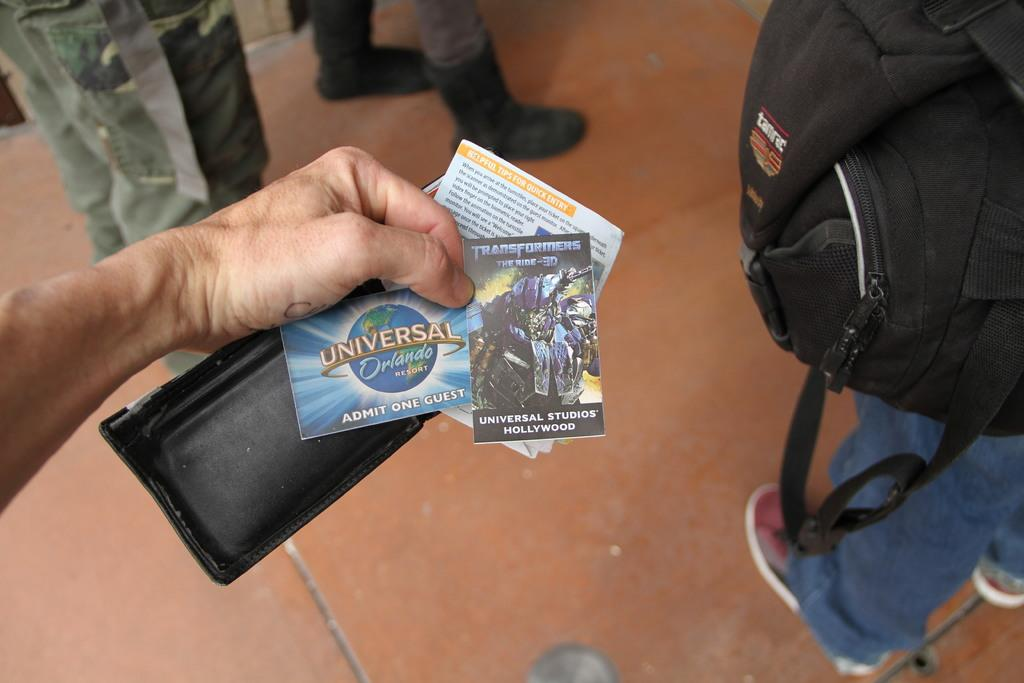What is the person holding in the image? The person is holding a purse and papers in the image. Can you describe the clothing or accessories of the other person in the image? There is a person wearing a black bag in the image. How many people are present in the image? There are people standing in the image. What type of yarn is the person using to hold the papers in the image? There is no yarn present in the image; the person is holding the papers with their hands. Can you see any jellyfish in the image? There are no jellyfish present in the image. 